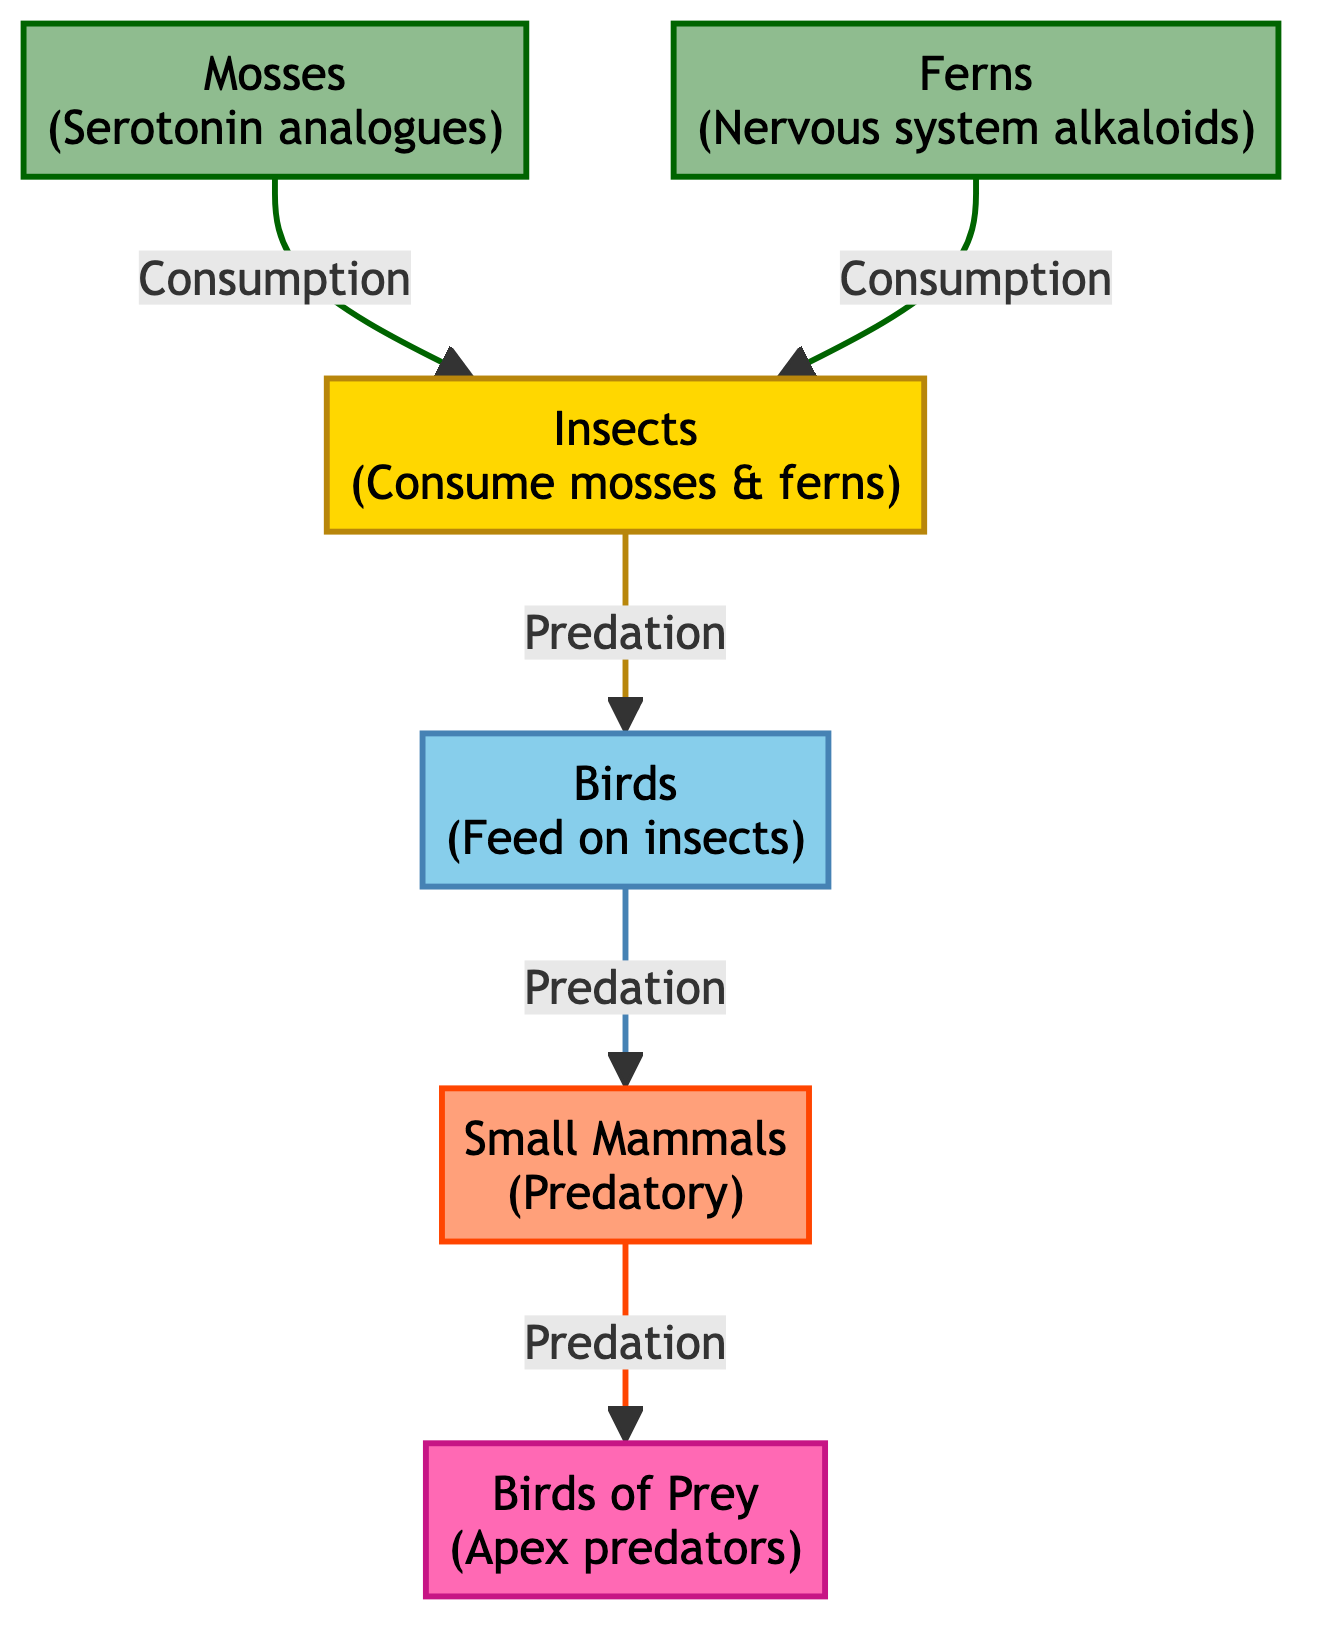What are the primary producers in this food chain? The diagram identifies "Mosses" and "Ferns" as the primary producers, which are at the beginning of the flow leading into herbivores.
Answer: Mosses, Ferns Which type of organism consumes mosses and ferns? The herbivore node in the diagram shows that "Insects" consume both mosses and ferns, indicating their role in the food chain.
Answer: Insects How many nodes are in the diagram? By counting all the distinct entities illustrated, we find there are six nodes in total: two primary producers, one herbivore, one secondary consumer, one tertiary consumer, and one apex predator.
Answer: 6 What is the relationship between insects and birds? The diagram shows that "Insects" are preyed upon by "Birds," illustrating a predator-prey relationship between these two types of organisms.
Answer: Predation Which organism is at the apex of the food chain? The apex predator is denoted at the end of the flow with “Birds of Prey,” which is the highest level in this food chain.
Answer: Birds of Prey What type of compounds do ferns contain? The diagram specifies that ferns are associated with "nervous system alkaloids," which indicates the chemical compounds found in them.
Answer: Nervous system alkaloids How many levels of predation are there in this food chain? Tracing the connections in the diagram, we can identify three levels of predation: from insects to birds, birds to small mammals, and small mammals to birds of prey.
Answer: 3 What is the primary function of mosses in this food chain? Mosses serve as a source of "serotonin analogues," which modulate neurotransmitter activity, indicating their role in the ecosystem's energy flow and chemical dynamics.
Answer: Serotonin analogues Which level comes after secondary consumers in this food chain? The diagram shows that the level following secondary consumers, which are birds, is tertiary consumers, specifically "Small Mammals."
Answer: Small Mammals 